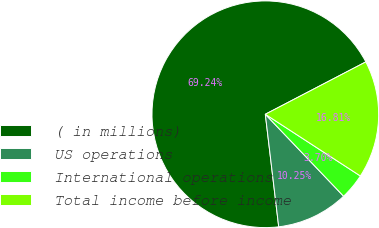Convert chart. <chart><loc_0><loc_0><loc_500><loc_500><pie_chart><fcel>( in millions)<fcel>US operations<fcel>International operations<fcel>Total income before income<nl><fcel>69.24%<fcel>10.25%<fcel>3.7%<fcel>16.81%<nl></chart> 